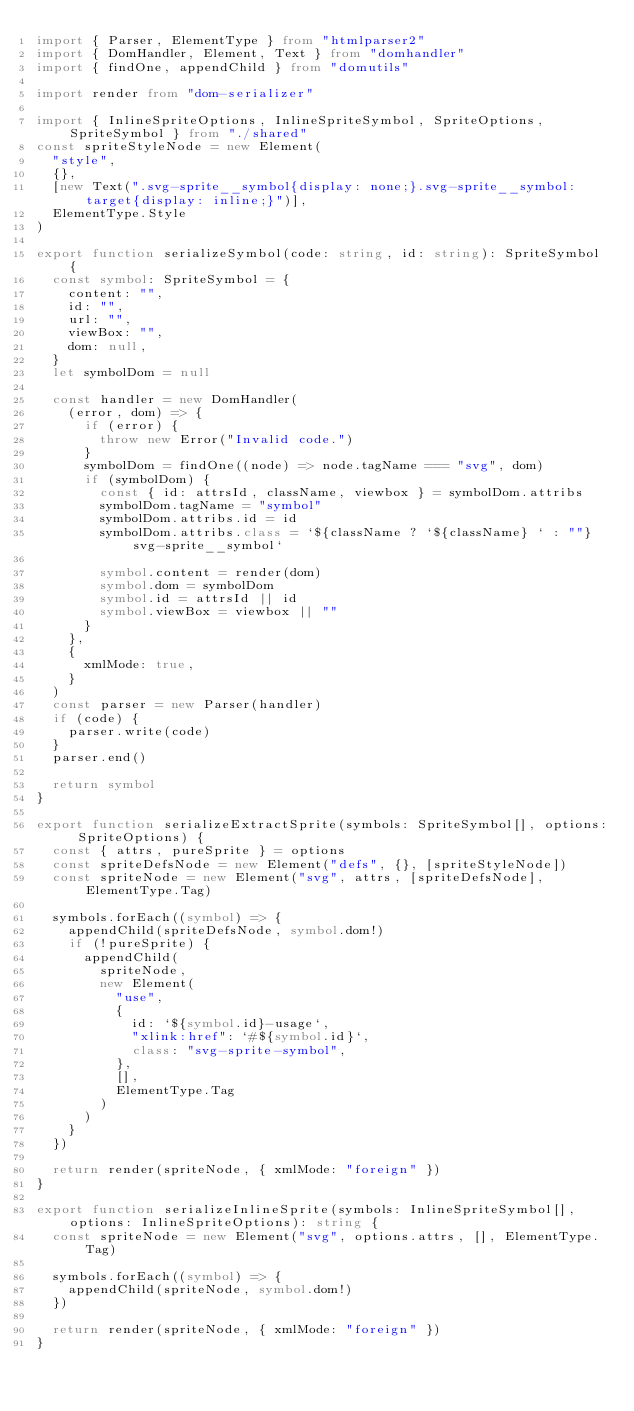Convert code to text. <code><loc_0><loc_0><loc_500><loc_500><_TypeScript_>import { Parser, ElementType } from "htmlparser2"
import { DomHandler, Element, Text } from "domhandler"
import { findOne, appendChild } from "domutils"

import render from "dom-serializer"

import { InlineSpriteOptions, InlineSpriteSymbol, SpriteOptions, SpriteSymbol } from "./shared"
const spriteStyleNode = new Element(
  "style",
  {},
  [new Text(".svg-sprite__symbol{display: none;}.svg-sprite__symbol:target{display: inline;}")],
  ElementType.Style
)

export function serializeSymbol(code: string, id: string): SpriteSymbol {
  const symbol: SpriteSymbol = {
    content: "",
    id: "",
    url: "",
    viewBox: "",
    dom: null,
  }
  let symbolDom = null

  const handler = new DomHandler(
    (error, dom) => {
      if (error) {
        throw new Error("Invalid code.")
      }
      symbolDom = findOne((node) => node.tagName === "svg", dom)
      if (symbolDom) {
        const { id: attrsId, className, viewbox } = symbolDom.attribs
        symbolDom.tagName = "symbol"
        symbolDom.attribs.id = id
        symbolDom.attribs.class = `${className ? `${className} ` : ""}svg-sprite__symbol`

        symbol.content = render(dom)
        symbol.dom = symbolDom
        symbol.id = attrsId || id
        symbol.viewBox = viewbox || ""
      }
    },
    {
      xmlMode: true,
    }
  )
  const parser = new Parser(handler)
  if (code) {
    parser.write(code)
  }
  parser.end()

  return symbol
}

export function serializeExtractSprite(symbols: SpriteSymbol[], options: SpriteOptions) {
  const { attrs, pureSprite } = options
  const spriteDefsNode = new Element("defs", {}, [spriteStyleNode])
  const spriteNode = new Element("svg", attrs, [spriteDefsNode], ElementType.Tag)

  symbols.forEach((symbol) => {
    appendChild(spriteDefsNode, symbol.dom!)
    if (!pureSprite) {
      appendChild(
        spriteNode,
        new Element(
          "use",
          {
            id: `${symbol.id}-usage`,
            "xlink:href": `#${symbol.id}`,
            class: "svg-sprite-symbol",
          },
          [],
          ElementType.Tag
        )
      )
    }
  })

  return render(spriteNode, { xmlMode: "foreign" })
}

export function serializeInlineSprite(symbols: InlineSpriteSymbol[], options: InlineSpriteOptions): string {
  const spriteNode = new Element("svg", options.attrs, [], ElementType.Tag)

  symbols.forEach((symbol) => {
    appendChild(spriteNode, symbol.dom!)
  })

  return render(spriteNode, { xmlMode: "foreign" })
}
</code> 